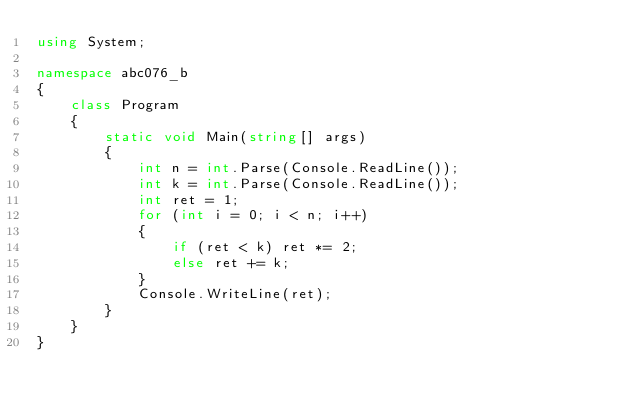<code> <loc_0><loc_0><loc_500><loc_500><_C#_>using System;

namespace abc076_b
{
    class Program
    {
        static void Main(string[] args)
        {
            int n = int.Parse(Console.ReadLine());
            int k = int.Parse(Console.ReadLine());
            int ret = 1;
            for (int i = 0; i < n; i++)
            {
                if (ret < k) ret *= 2;
                else ret += k;
            }
            Console.WriteLine(ret);
        }
    }
}</code> 